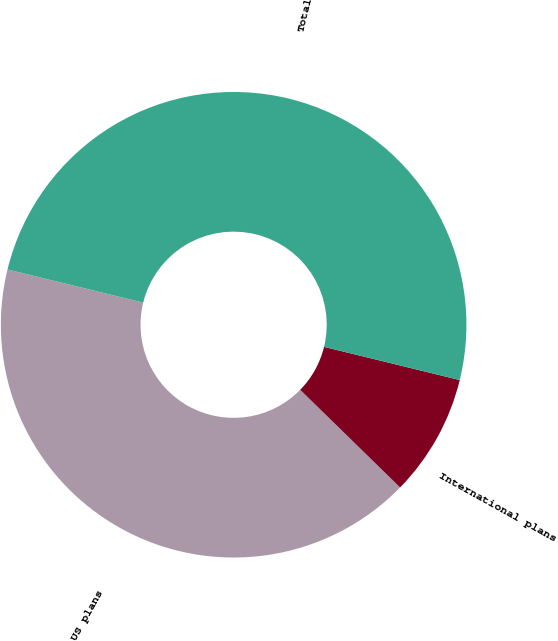Convert chart to OTSL. <chart><loc_0><loc_0><loc_500><loc_500><pie_chart><fcel>US plans<fcel>International plans<fcel>Total<nl><fcel>41.5%<fcel>8.5%<fcel>50.0%<nl></chart> 